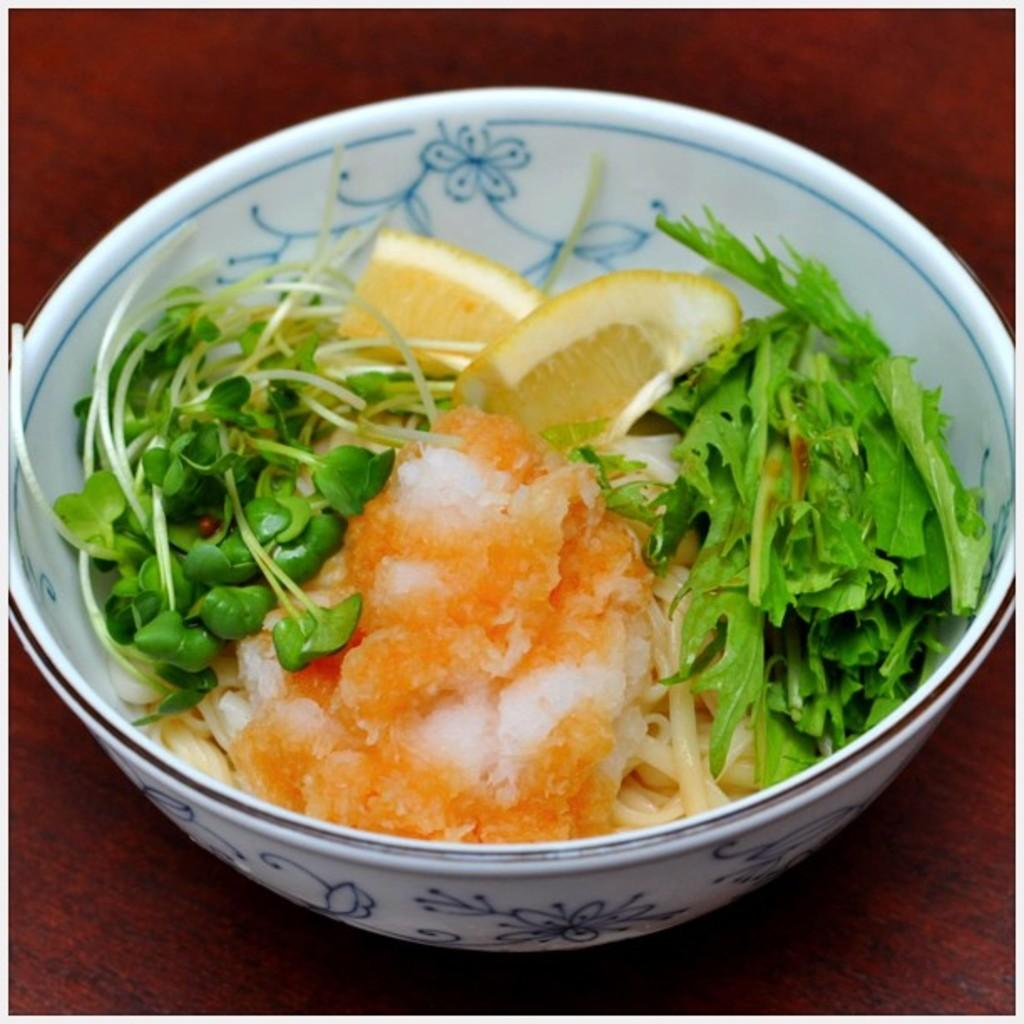What is present on the table in the image? There is a bowl on the table in the image. What is inside the bowl? The bowl contains fruits and vegetables. Can you describe the contents of the bowl in more detail? The bowl contains a mix of fruits and vegetables. How does the loss of time affect the flight of the fruits and vegetables in the image? There is no mention of time or flight in the image, and the fruits and vegetables are not depicted as flying or being affected by time. 